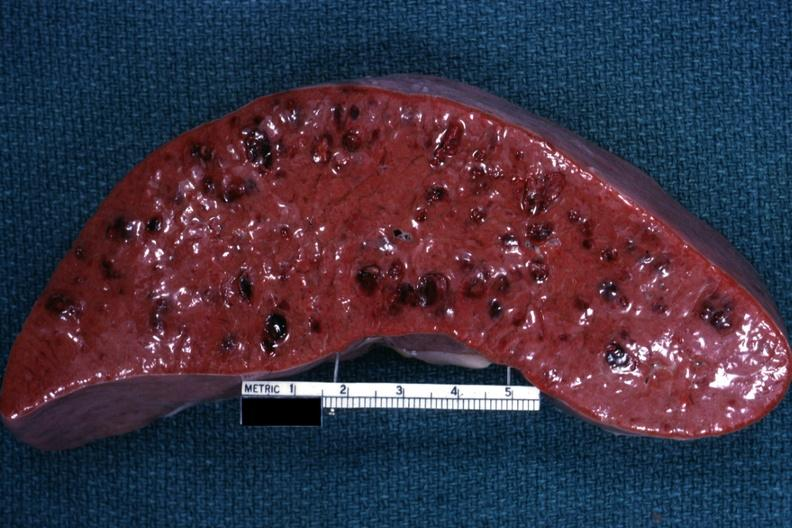s autopsy present?
Answer the question using a single word or phrase. No 